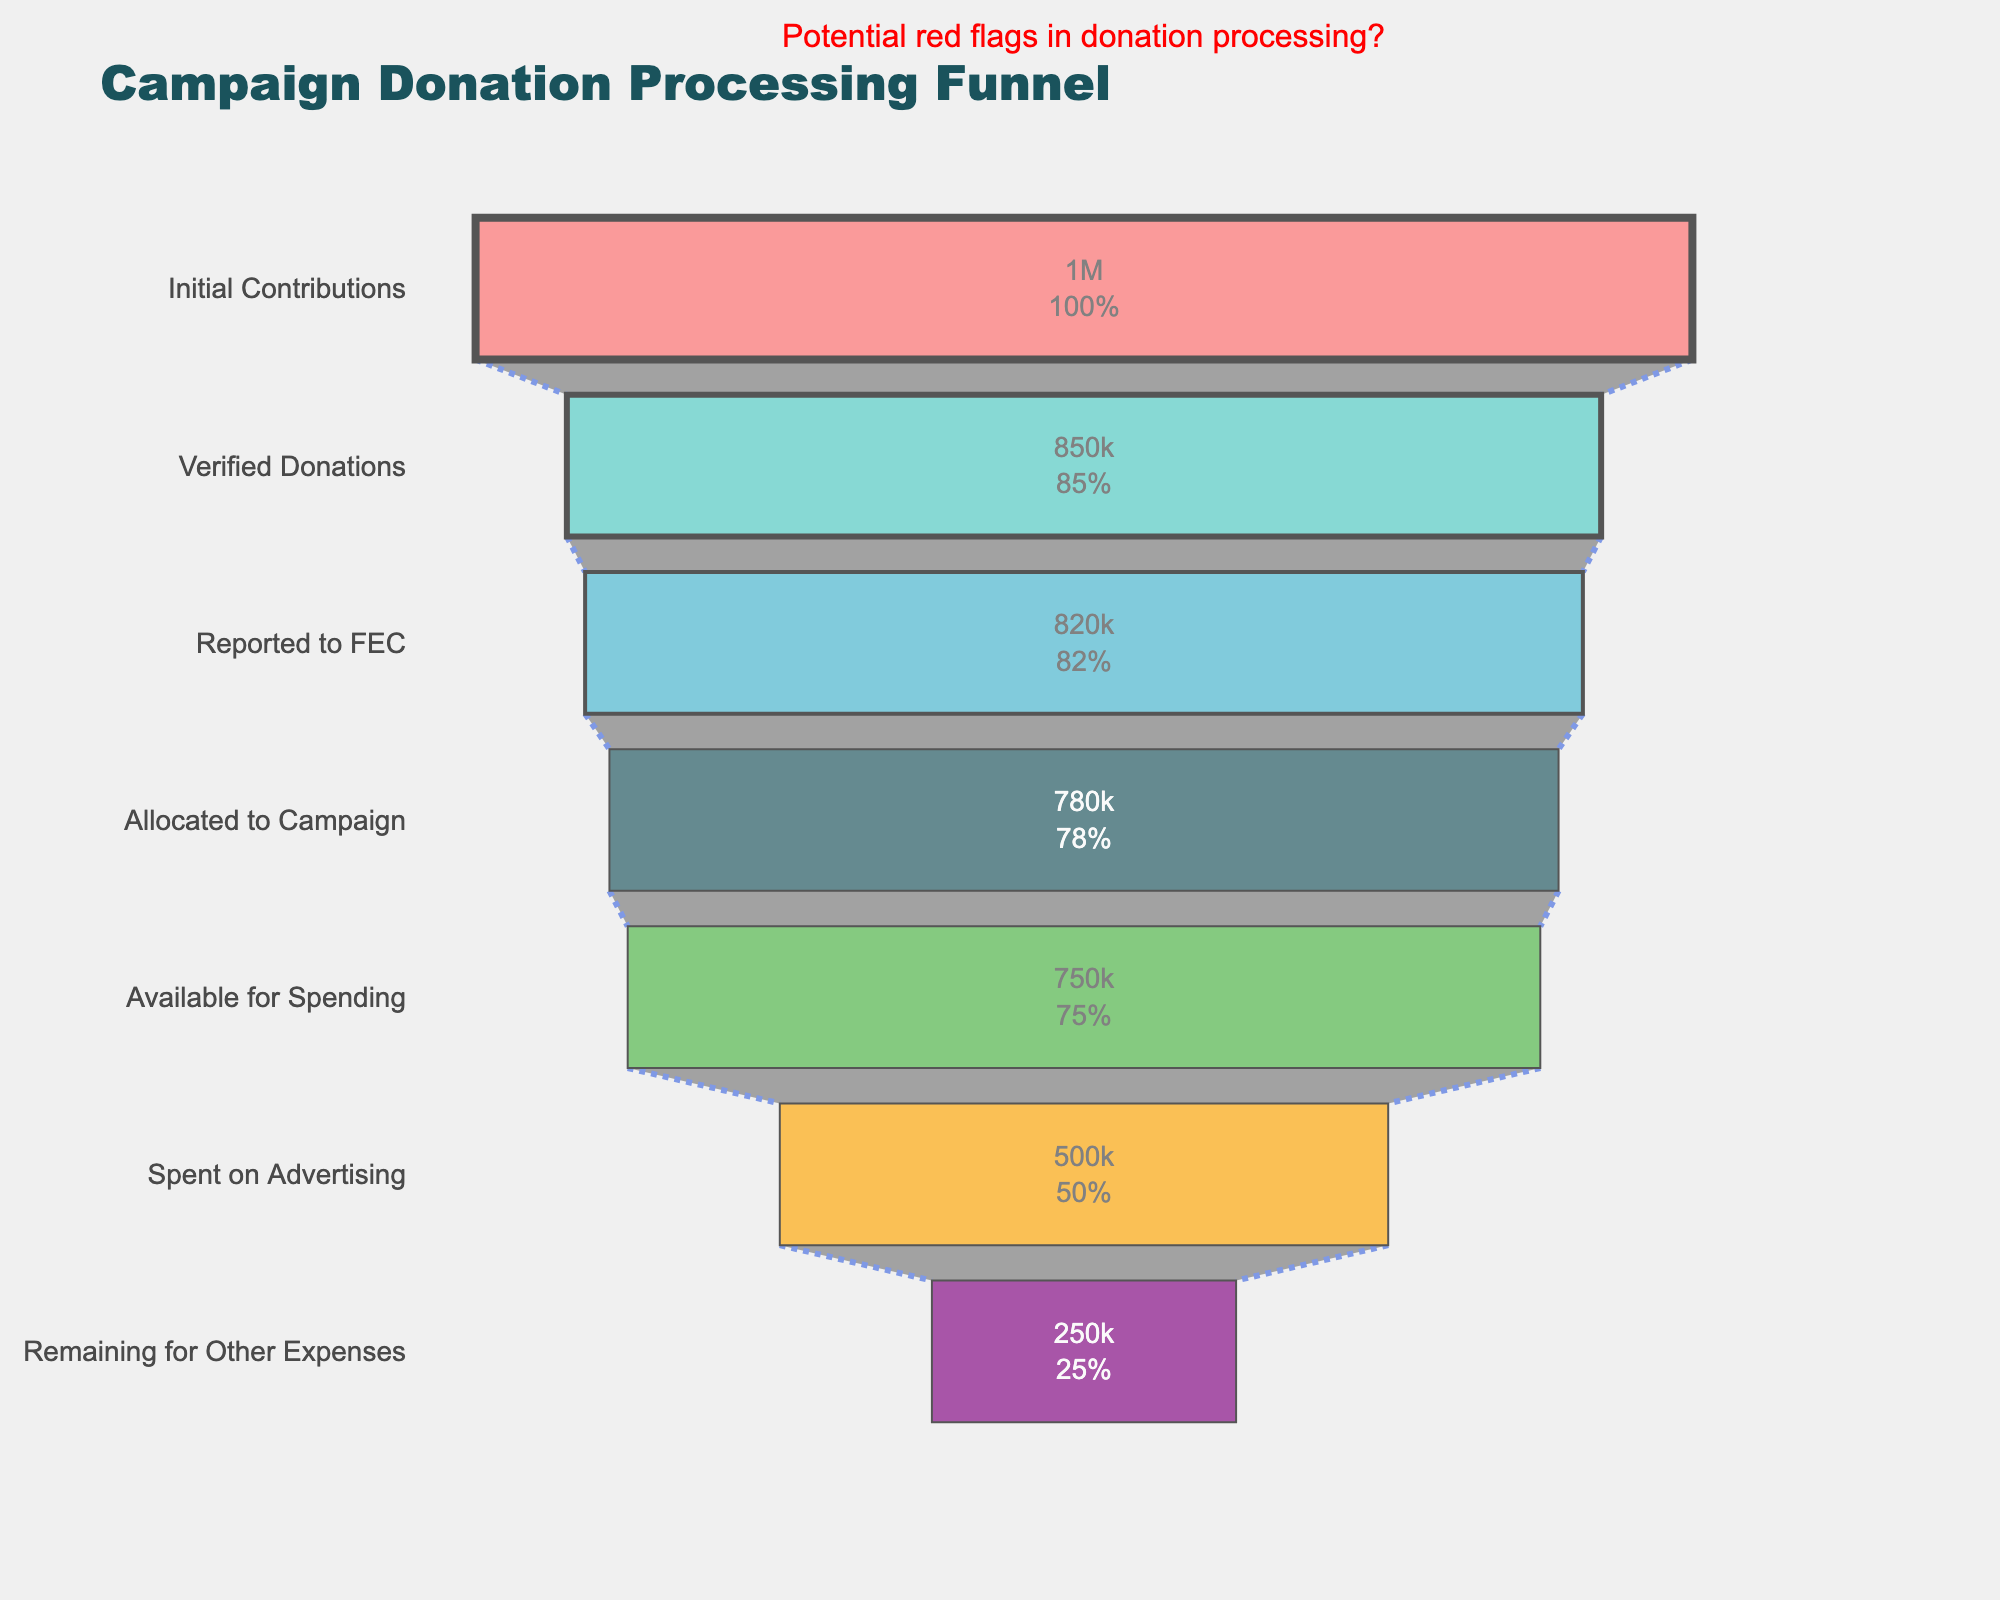What's the title of the figure? Read the title text at the top of the figure.
Answer: Campaign Donation Processing Funnel How much money is left after spending on advertising? Locate the corresponding stage 'Remaining for Other Expenses' and read its value.
Answer: 250,000 What percentage of the initial contributions has been allocated to the campaign? Compare the amount at 'Allocated to Campaign' with the 'Initial Contributions'. Calculate the percentage as (780,000 / 1,000,000) * 100.
Answer: 78% How does the amount spent on advertising compare to the amount available for spending? Examine the amounts for 'Spent on Advertising' and 'Available for Spending'. The amount for advertising (500,000) is less than the amount available (750,000).
Answer: Less by 250,000 What's the difference between the verified donations and reported donations to FEC? Calculate the difference by subtracting 'Reported to FEC' amount from 'Verified Donations'. 850,000 - 820,000 = 30,000.
Answer: 30,000 What's the sum of the amounts reported to FEC and available for spending? Add the amounts at stages 'Reported to FEC' and 'Available for Spending'. 820,000 + 750,000 = 1,570,000.
Answer: 1,570,000 Which stage has the largest drop in amount from the previous stage? Identify the largest decrease by comparing consecutive stages: Initial Contributions to Verified Donations (150,000), Verified Donations to Reported to FEC (30,000), etc. The largest drop is from Initial Contributions to Verified Donations.
Answer: Initial Contributions to Verified Donations What color represents the stage 'Allocated to Campaign'? Identify the color of the bar corresponding to the 'Allocated to Campaign' stage on the plot. It is provided as #1A535C in the code, which is a dark teal.
Answer: Dark teal How much money is lost between 'Allocated to Campaign' and 'Available for Spending'? Calculate the difference between the amounts in these two stages: 780,000 - 750,000 = 30,000.
Answer: 30,000 What percentage of the funds are spent on advertising out of the available for spending amount? Calculate the percentage as (500,000 / 750,000) * 100.
Answer: 66.67% 